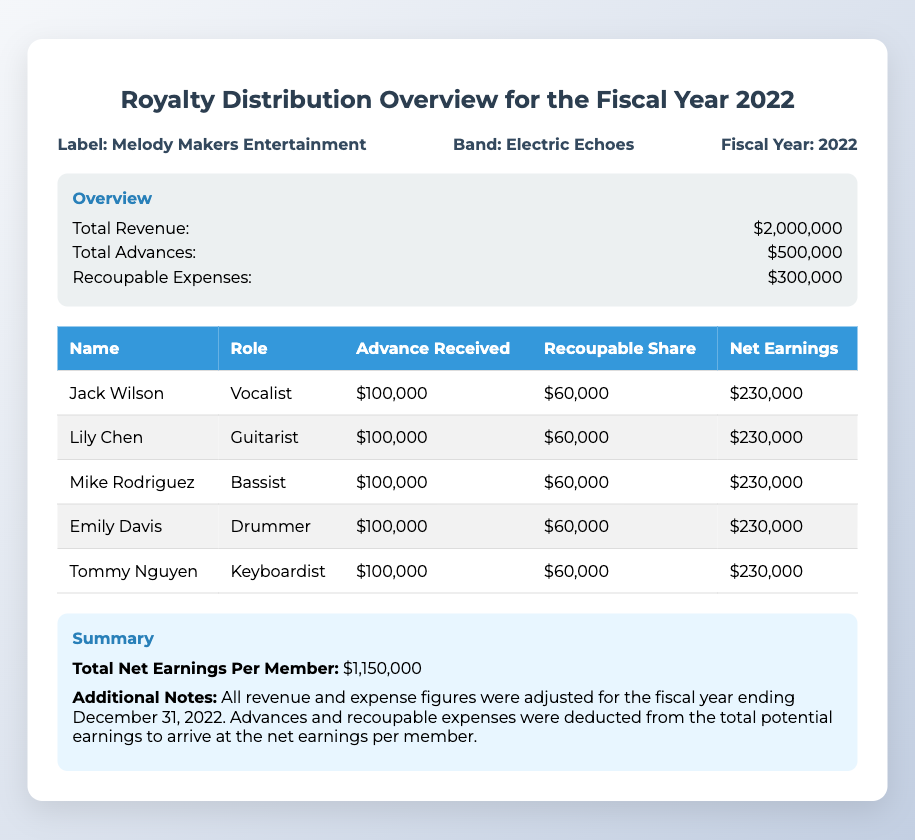What is the total revenue? The total revenue listed in the document is directly provided in the overview section as $2,000,000.
Answer: $2,000,000 How much were the total advances? The total advances are found in the overview section and amount to $500,000.
Answer: $500,000 What were the recoupable expenses? The recoupable expenses are mentioned in the overview section, totaling $300,000.
Answer: $300,000 Who is the bassist? The document lists Mike Rodriguez as the bassist in the table of members.
Answer: Mike Rodriguez What is the net earnings per member? The total net earnings per member is summarized in the document as $1,150,000.
Answer: $1,150,000 How many members received an advance of $100,000? The table indicates that all five members received an advance of $100,000 each.
Answer: Five What is the role of Lily Chen? In the document, Lily Chen is identified as the guitarist.
Answer: Guitarist What color is the header background in the table? The header background color is specified in the style section as blue, corresponding to the content in the table.
Answer: Blue What is the additional note regarding earnings? The summary section provides the additional note that explains how advances and recoupable expenses were deducted from potential earnings to find net earnings.
Answer: Adjusted for the fiscal year ending December 31, 2022 